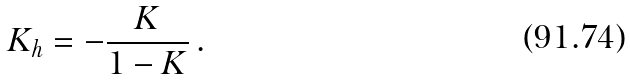<formula> <loc_0><loc_0><loc_500><loc_500>K _ { h } = - \frac { K } { 1 - K } \, .</formula> 